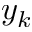<formula> <loc_0><loc_0><loc_500><loc_500>y _ { k }</formula> 